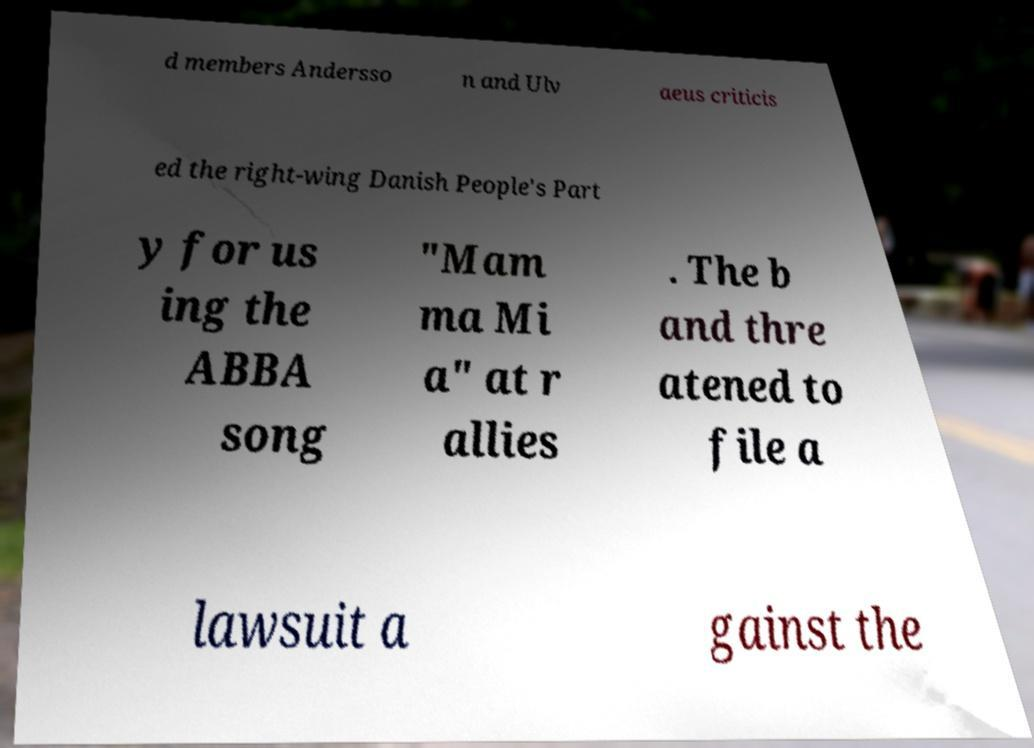Please read and relay the text visible in this image. What does it say? d members Andersso n and Ulv aeus criticis ed the right-wing Danish People's Part y for us ing the ABBA song "Mam ma Mi a" at r allies . The b and thre atened to file a lawsuit a gainst the 